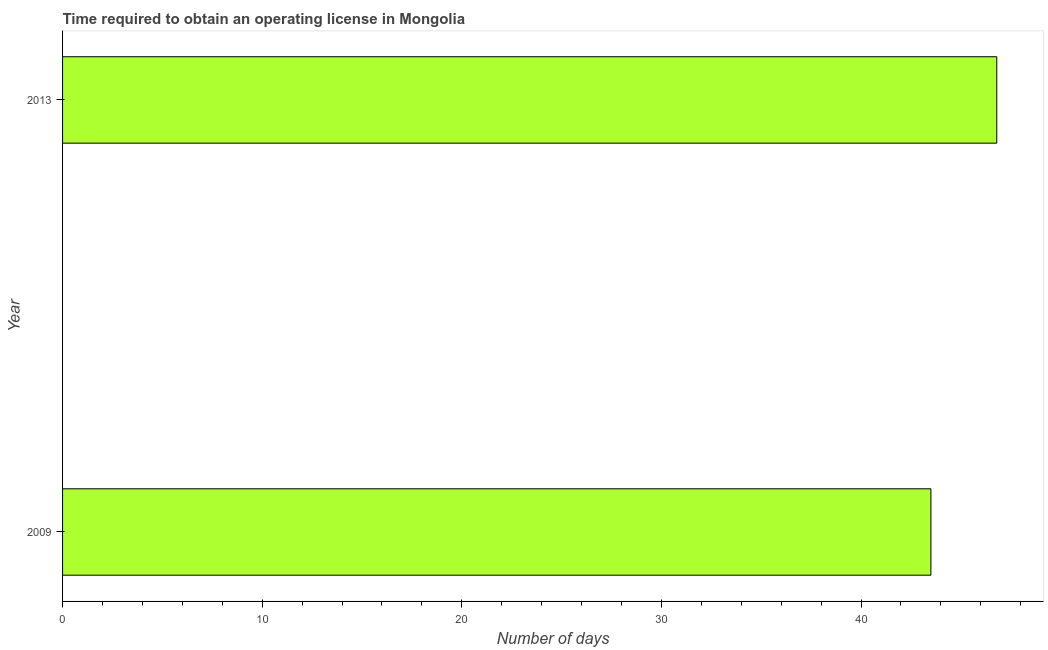Does the graph contain any zero values?
Ensure brevity in your answer.  No. Does the graph contain grids?
Your response must be concise. No. What is the title of the graph?
Make the answer very short. Time required to obtain an operating license in Mongolia. What is the label or title of the X-axis?
Your response must be concise. Number of days. What is the label or title of the Y-axis?
Your answer should be compact. Year. What is the number of days to obtain operating license in 2013?
Your answer should be compact. 46.8. Across all years, what is the maximum number of days to obtain operating license?
Your response must be concise. 46.8. Across all years, what is the minimum number of days to obtain operating license?
Your answer should be compact. 43.5. What is the sum of the number of days to obtain operating license?
Your answer should be compact. 90.3. What is the average number of days to obtain operating license per year?
Your answer should be very brief. 45.15. What is the median number of days to obtain operating license?
Offer a very short reply. 45.15. What is the ratio of the number of days to obtain operating license in 2009 to that in 2013?
Ensure brevity in your answer.  0.93. Is the number of days to obtain operating license in 2009 less than that in 2013?
Make the answer very short. Yes. In how many years, is the number of days to obtain operating license greater than the average number of days to obtain operating license taken over all years?
Ensure brevity in your answer.  1. How many bars are there?
Provide a short and direct response. 2. How many years are there in the graph?
Make the answer very short. 2. What is the difference between two consecutive major ticks on the X-axis?
Ensure brevity in your answer.  10. Are the values on the major ticks of X-axis written in scientific E-notation?
Your response must be concise. No. What is the Number of days of 2009?
Ensure brevity in your answer.  43.5. What is the Number of days in 2013?
Your answer should be very brief. 46.8. What is the ratio of the Number of days in 2009 to that in 2013?
Provide a succinct answer. 0.93. 